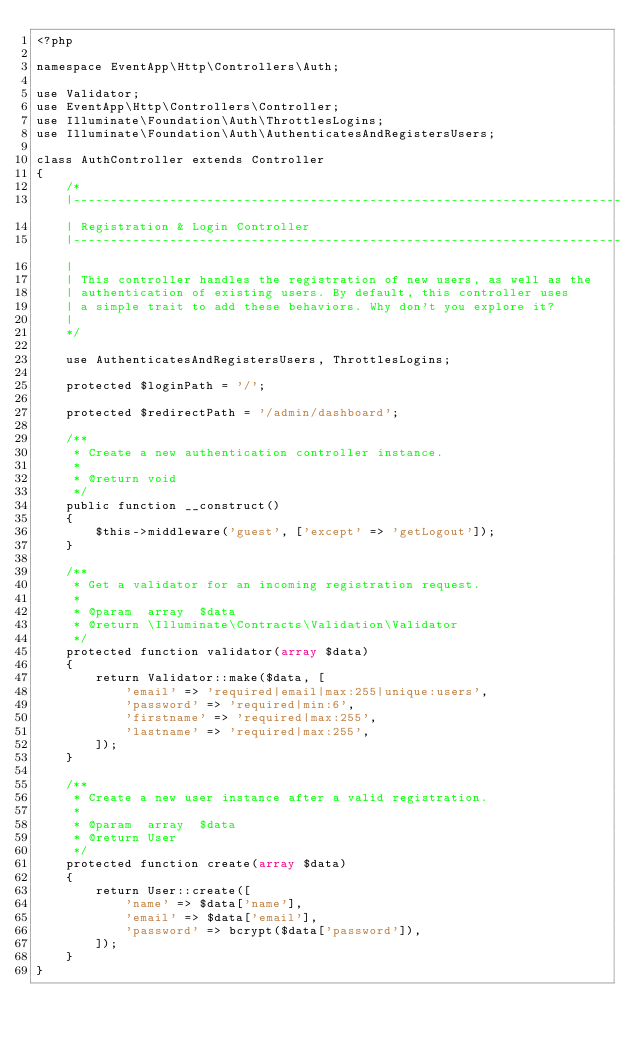Convert code to text. <code><loc_0><loc_0><loc_500><loc_500><_PHP_><?php

namespace EventApp\Http\Controllers\Auth;

use Validator;
use EventApp\Http\Controllers\Controller;
use Illuminate\Foundation\Auth\ThrottlesLogins;
use Illuminate\Foundation\Auth\AuthenticatesAndRegistersUsers;

class AuthController extends Controller
{
    /*
    |--------------------------------------------------------------------------
    | Registration & Login Controller
    |--------------------------------------------------------------------------
    |
    | This controller handles the registration of new users, as well as the
    | authentication of existing users. By default, this controller uses
    | a simple trait to add these behaviors. Why don't you explore it?
    |
    */

    use AuthenticatesAndRegistersUsers, ThrottlesLogins;

    protected $loginPath = '/';

    protected $redirectPath = '/admin/dashboard';

    /**
     * Create a new authentication controller instance.
     *
     * @return void
     */
    public function __construct()
    {
        $this->middleware('guest', ['except' => 'getLogout']);
    }

    /**
     * Get a validator for an incoming registration request.
     *
     * @param  array  $data
     * @return \Illuminate\Contracts\Validation\Validator
     */
    protected function validator(array $data)
    {
        return Validator::make($data, [
            'email' => 'required|email|max:255|unique:users',
            'password' => 'required|min:6',
            'firstname' => 'required|max:255',
            'lastname' => 'required|max:255',
        ]);
    }

    /**
     * Create a new user instance after a valid registration.
     *
     * @param  array  $data
     * @return User
     */
    protected function create(array $data)
    {
        return User::create([
            'name' => $data['name'],
            'email' => $data['email'],
            'password' => bcrypt($data['password']),
        ]);
    }
}
</code> 